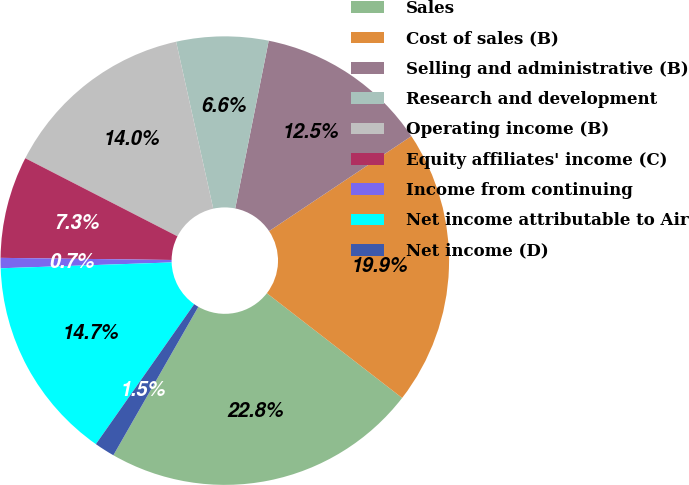Convert chart to OTSL. <chart><loc_0><loc_0><loc_500><loc_500><pie_chart><fcel>Sales<fcel>Cost of sales (B)<fcel>Selling and administrative (B)<fcel>Research and development<fcel>Operating income (B)<fcel>Equity affiliates' income (C)<fcel>Income from continuing<fcel>Net income attributable to Air<fcel>Net income (D)<nl><fcel>22.79%<fcel>19.85%<fcel>12.5%<fcel>6.62%<fcel>13.97%<fcel>7.35%<fcel>0.74%<fcel>14.71%<fcel>1.47%<nl></chart> 